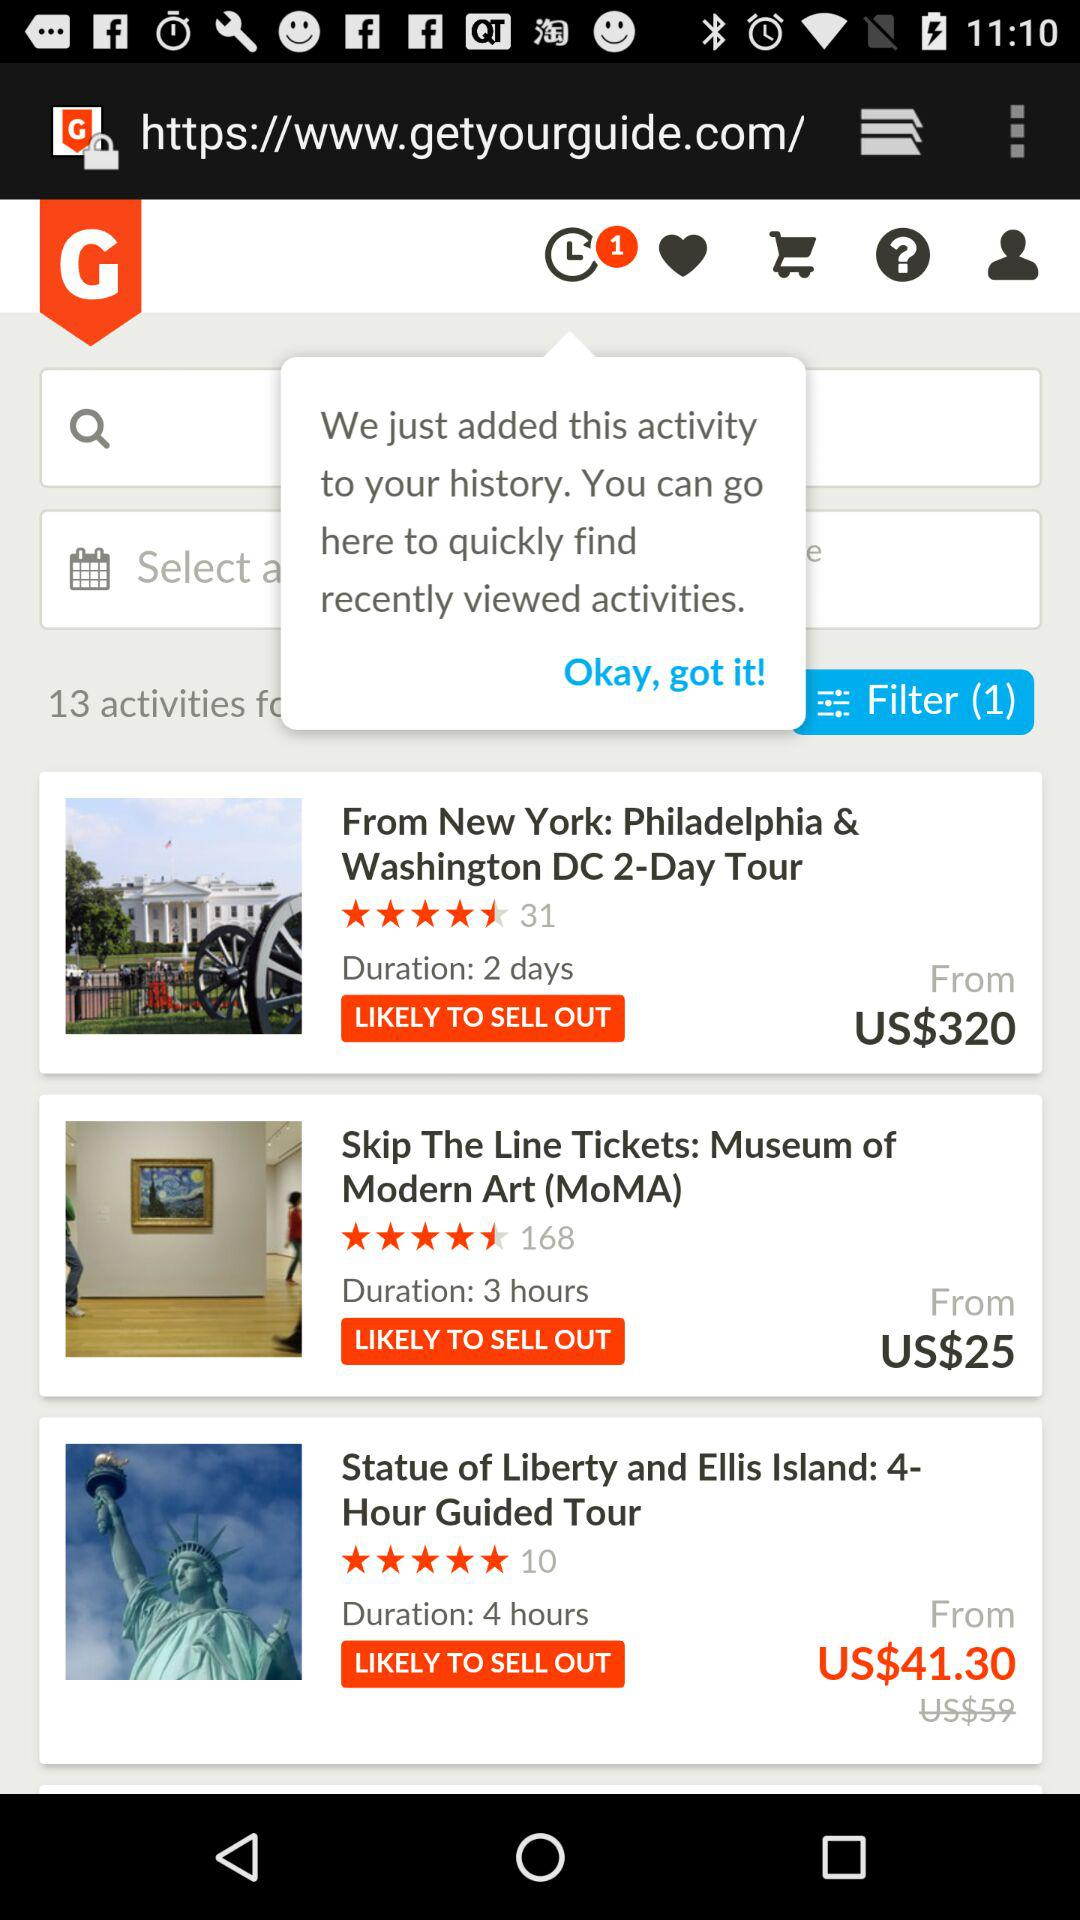What is the ticket price for "Museum of Modern Art (MoMA)"? The ticket price for "Museum of Modern Art (MoMA)" starts from US$25. 